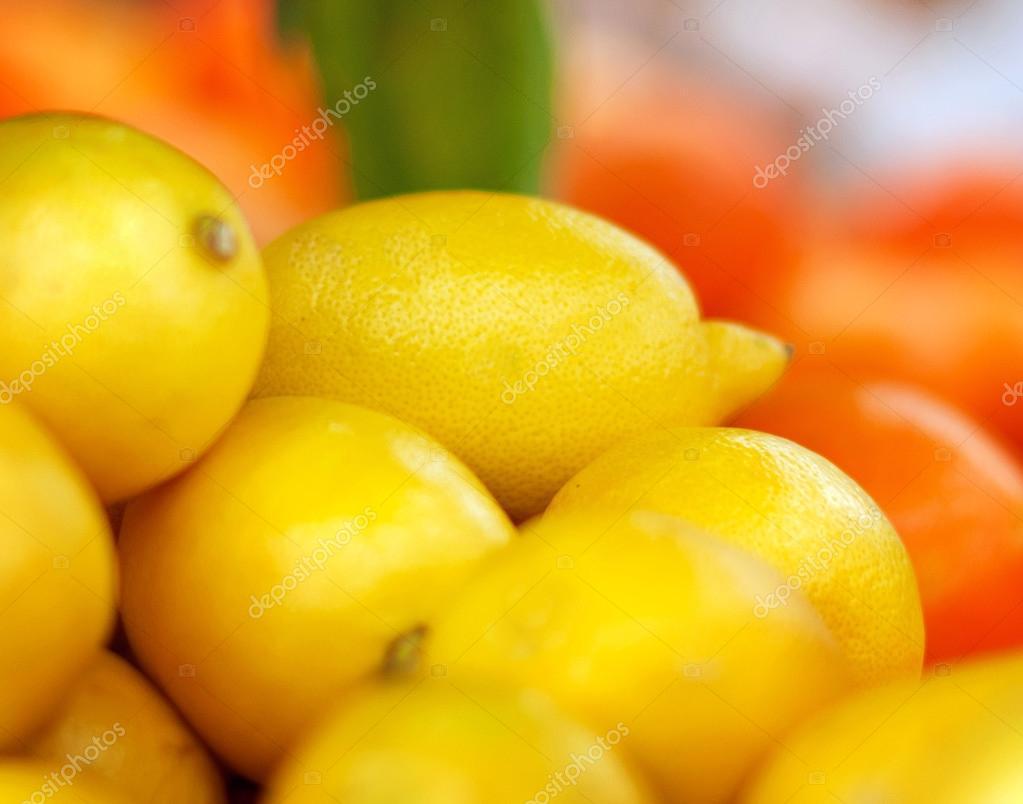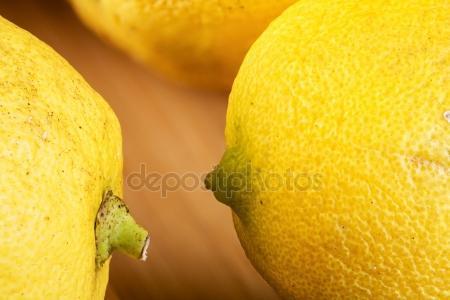The first image is the image on the left, the second image is the image on the right. Examine the images to the left and right. Is the description "There are at least two lemon halves that are cut open." accurate? Answer yes or no. No. The first image is the image on the left, the second image is the image on the right. For the images shown, is this caption "There is a sliced lemon in exactly one image." true? Answer yes or no. No. 